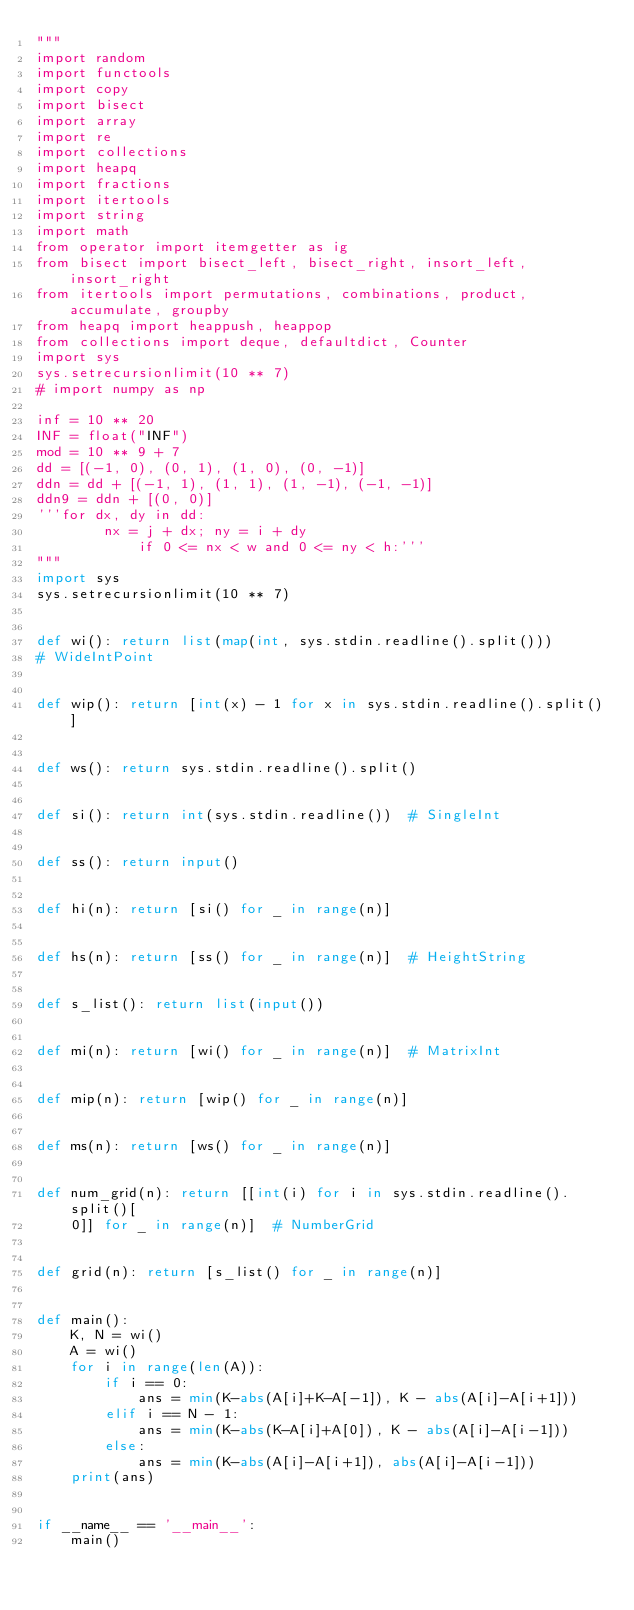Convert code to text. <code><loc_0><loc_0><loc_500><loc_500><_Python_>"""
import random
import functools
import copy
import bisect
import array
import re
import collections
import heapq
import fractions
import itertools
import string
import math
from operator import itemgetter as ig
from bisect import bisect_left, bisect_right, insort_left, insort_right
from itertools import permutations, combinations, product, accumulate, groupby
from heapq import heappush, heappop
from collections import deque, defaultdict, Counter
import sys
sys.setrecursionlimit(10 ** 7)
# import numpy as np

inf = 10 ** 20
INF = float("INF")
mod = 10 ** 9 + 7
dd = [(-1, 0), (0, 1), (1, 0), (0, -1)]
ddn = dd + [(-1, 1), (1, 1), (1, -1), (-1, -1)]
ddn9 = ddn + [(0, 0)]
'''for dx, dy in dd:
        nx = j + dx; ny = i + dy
            if 0 <= nx < w and 0 <= ny < h:'''
"""
import sys
sys.setrecursionlimit(10 ** 7)


def wi(): return list(map(int, sys.stdin.readline().split()))
# WideIntPoint


def wip(): return [int(x) - 1 for x in sys.stdin.readline().split()]


def ws(): return sys.stdin.readline().split()


def si(): return int(sys.stdin.readline())  # SingleInt


def ss(): return input()


def hi(n): return [si() for _ in range(n)]


def hs(n): return [ss() for _ in range(n)]  # HeightString


def s_list(): return list(input())


def mi(n): return [wi() for _ in range(n)]  # MatrixInt


def mip(n): return [wip() for _ in range(n)]


def ms(n): return [ws() for _ in range(n)]


def num_grid(n): return [[int(i) for i in sys.stdin.readline().split()[
    0]] for _ in range(n)]  # NumberGrid


def grid(n): return [s_list() for _ in range(n)]


def main():
    K, N = wi()
    A = wi()
    for i in range(len(A)):
        if i == 0:
            ans = min(K-abs(A[i]+K-A[-1]), K - abs(A[i]-A[i+1]))
        elif i == N - 1:
            ans = min(K-abs(K-A[i]+A[0]), K - abs(A[i]-A[i-1]))
        else:
            ans = min(K-abs(A[i]-A[i+1]), abs(A[i]-A[i-1]))
    print(ans)


if __name__ == '__main__':
    main()
</code> 